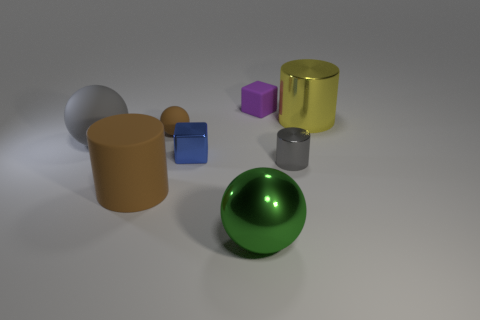Add 1 large green rubber things. How many objects exist? 9 Subtract all cylinders. How many objects are left? 5 Subtract all rubber blocks. Subtract all yellow things. How many objects are left? 6 Add 3 tiny gray shiny cylinders. How many tiny gray shiny cylinders are left? 4 Add 6 purple rubber things. How many purple rubber things exist? 7 Subtract 0 purple cylinders. How many objects are left? 8 